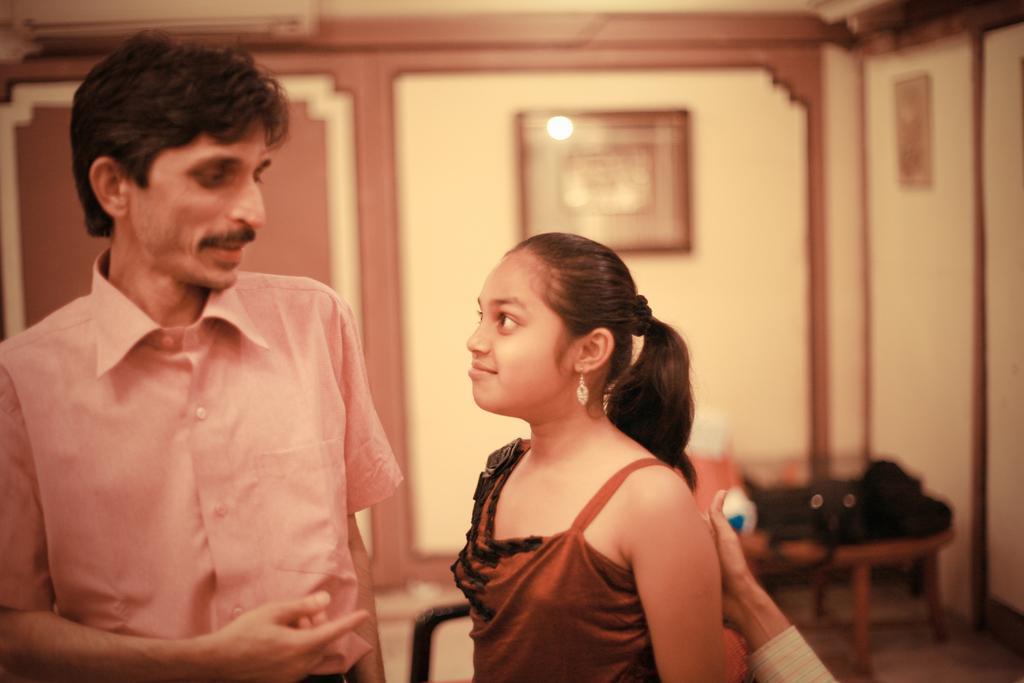Please provide a concise description of this image. In this image we can see two persons are standing, there a man is standing, beside a girl is standing, there is a wall and photo frames on it, there is a table and some objects on it, there it is blur. 